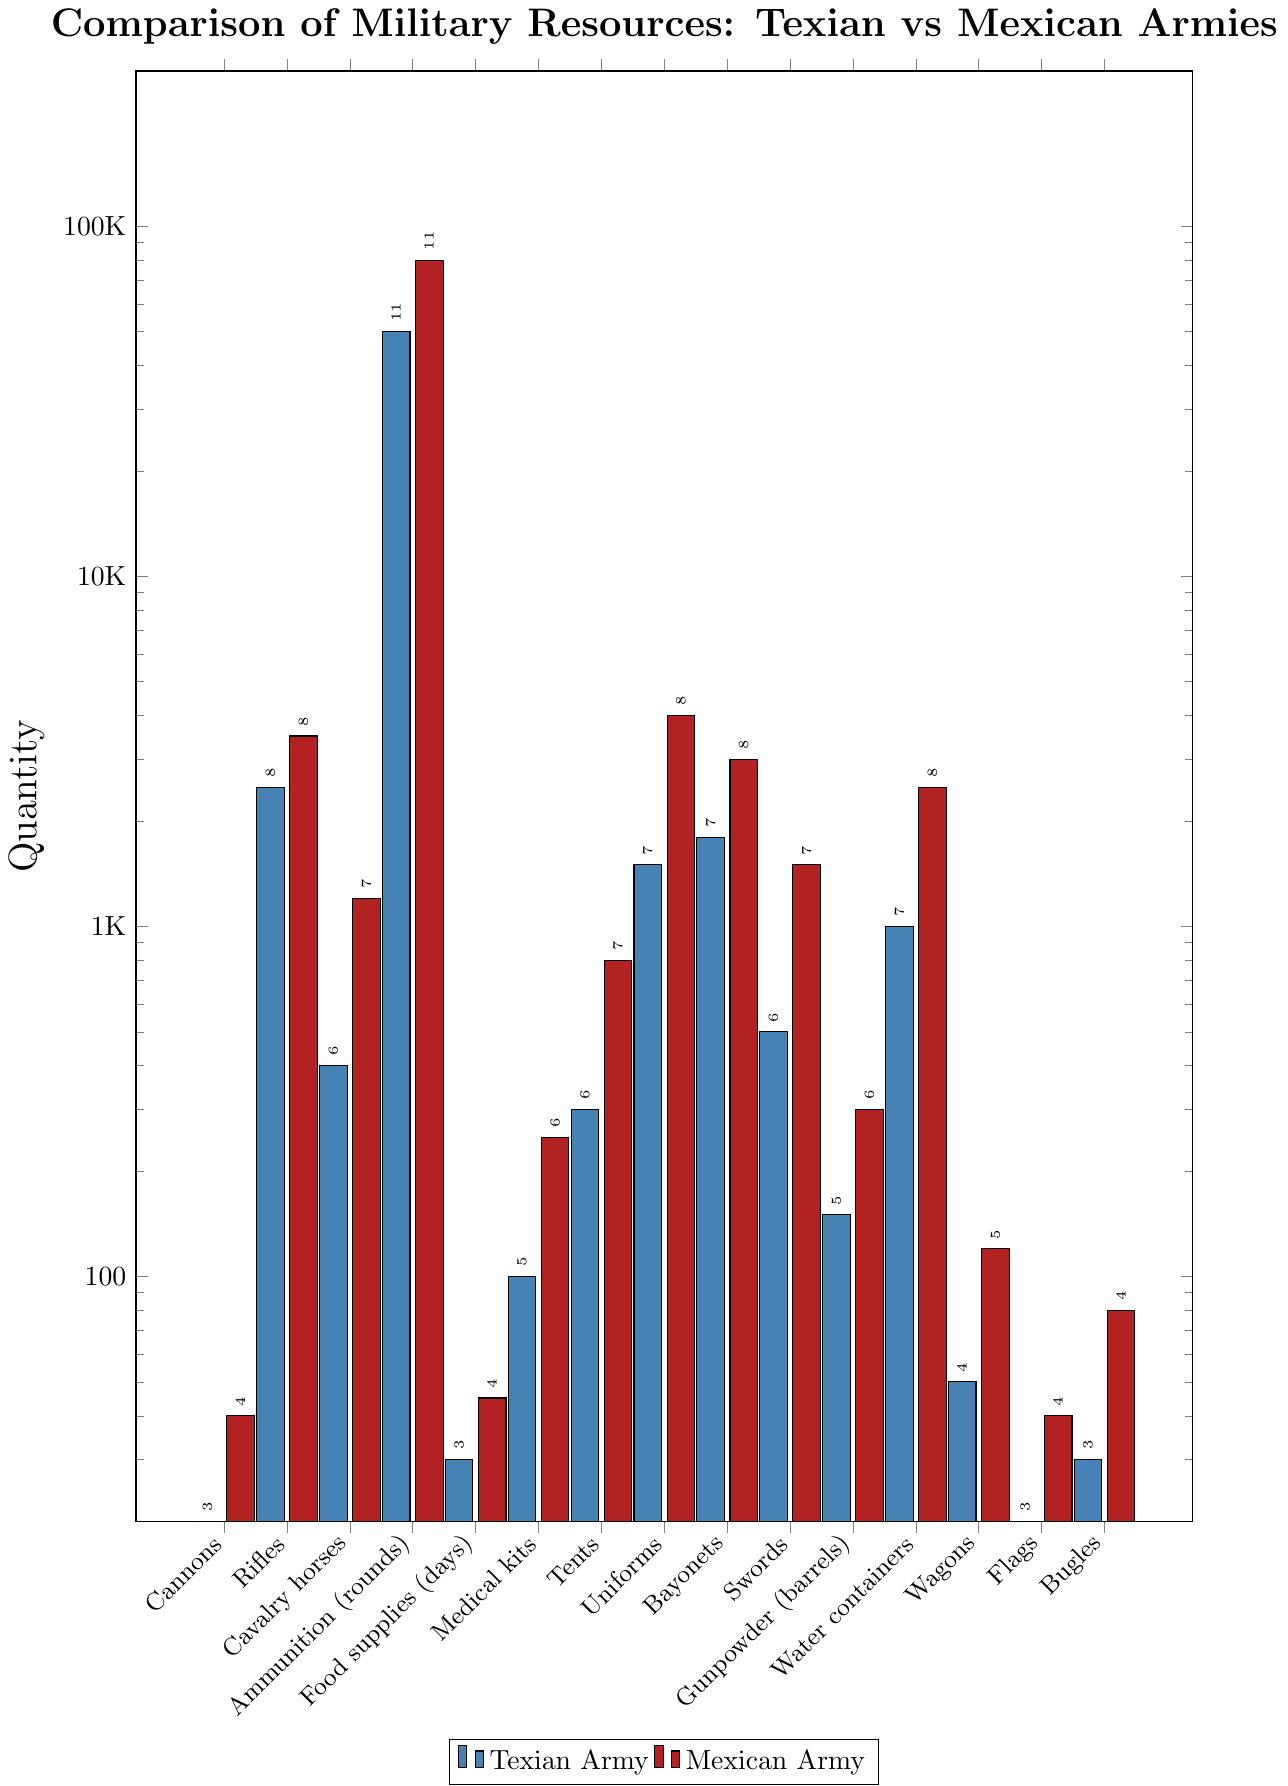What resource has the greatest numerical difference between the Texian and Mexican armies? To find the numerical difference for each resource, subtract the amount available to the Texian Army from the amount available to the Mexican Army for each category. The largest difference is found with uniforms: 4000 (Mexican Army) - 1500 (Texian Army) = 2500.
Answer: Uniforms Which army had more rifles and by how many? Mexican Army had 3500 rifles while Texian Army had 2500. The difference between them is 3500 - 2500 = 1000.
Answer: Mexican Army, 1000 Are there more bayonets or swords in the Texian Army? The Texian Army has 1800 bayonets and 500 swords. By comparing these numbers, we see there are more bayonets.
Answer: Bayonets Which resource has the smallest quantity in the Texian Army? Looking at the bar chart, the resource with the smallest quantity for the Texian Army is cannons with 20 units.
Answer: Cannons What is the total number of medical kits and water containers in both armies combined? For the Texian Army: 100 medical kits + 1000 water containers = 1100. For the Mexican Army: 250 medical kits + 2500 water containers = 2750. Combing both: 1100 + 2750 = 3850.
Answer: 3850 Which army has more wagons, and what's the ratio of wagons between the two armies? The Mexican Army has 120 wagons whereas the Texian Army has 50 wagons. The ratio of Mexican Army wagons to Texian Army wagons is 120:50, which simplifies to 12:5.
Answer: Mexican Army, 12:5 By what factor does the number of tent provided by the Mexican Army exceed that of the Texian Army? The Mexican Army has 800 tents and the Texian Army has 300. The factor by which the Mexican Army exceeds the Texian Army is 800 ÷ 300 = 2.67.
Answer: 2.67 Is the quantity of bugles in the Texian Army greater than the quantity of flags in the Mexican Army? The Texian Army has 30 bugles and the Mexican Army has 40 flags. Since 30 < 40, the quantity of bugles in the Texian Army is not greater than the quantity of flags in the Mexican Army.
Answer: No Are rifles more abundant in the Texian Army than food supplies (days) in the Mexican Army? The Texian Army has 2500 rifles, and the Mexican Army has 45 days of food supplies. Since 2500 > 45, rifles are more abundant in the Texian Army compared to food supplies (days) in the Mexican Army.
Answer: Yes How many more resources does the Mexican Army have, on average, compared to the Texian Army? For each category, find the difference, then calculate the average difference across all categories: Differences: (20, 1000, 800, 30000, 15, 150, 500, 2500, 1200, 1000, 150, 1500, 70, 20, 50). The average is (20 + 1000 + 800 + 30000 + 15 + 150 + 500 + 2500 + 1200 + 1000 + 150 + 1500 + 70 + 20 + 50) / 15 ≈ 2470.
Answer: 2470 